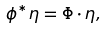Convert formula to latex. <formula><loc_0><loc_0><loc_500><loc_500>\phi ^ { * } \eta = \Phi \cdot \eta ,</formula> 